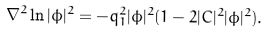Convert formula to latex. <formula><loc_0><loc_0><loc_500><loc_500>\nabla ^ { 2 } \ln | \phi | ^ { 2 } = - q _ { 1 } ^ { 2 } | \phi | ^ { 2 } ( 1 - 2 | C | ^ { 2 } | \phi | ^ { 2 } ) .</formula> 